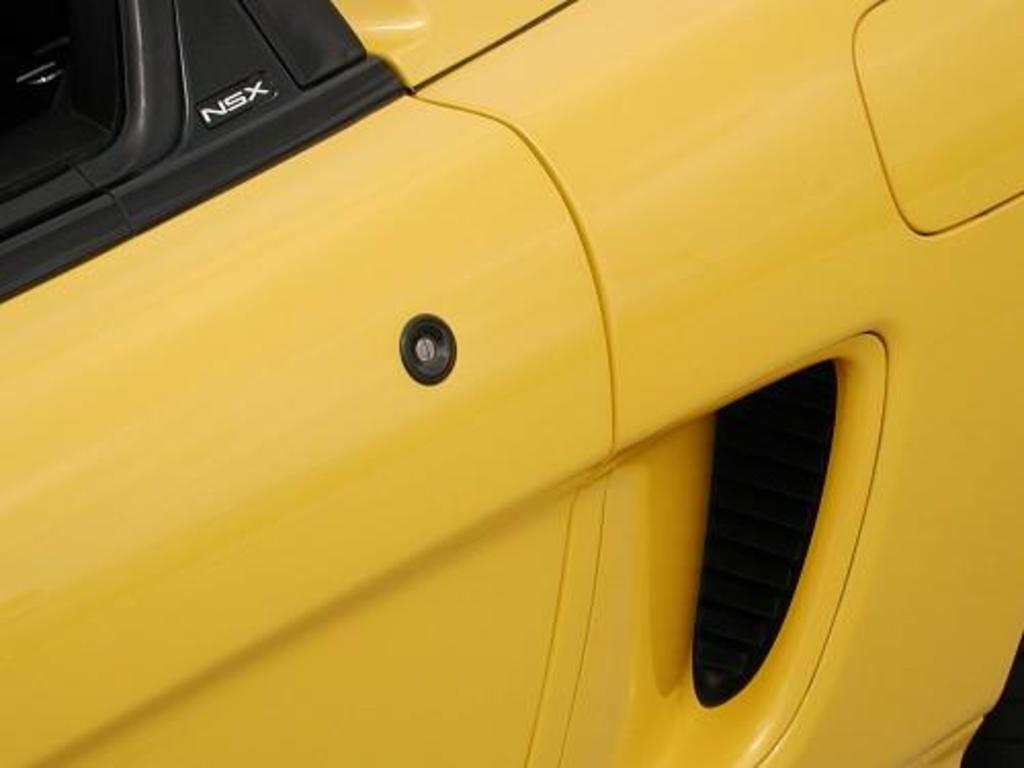How would you summarize this image in a sentence or two? In this image we can see a car which is in yellow color. 